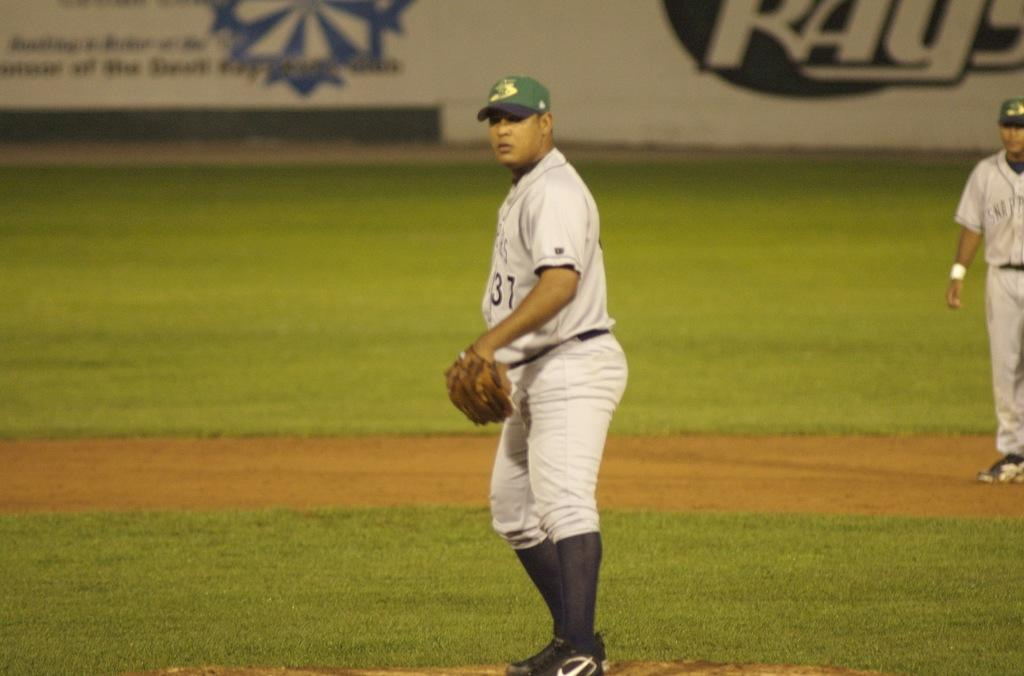<image>
Render a clear and concise summary of the photo. a baseball player wearing the number 31 jersey 